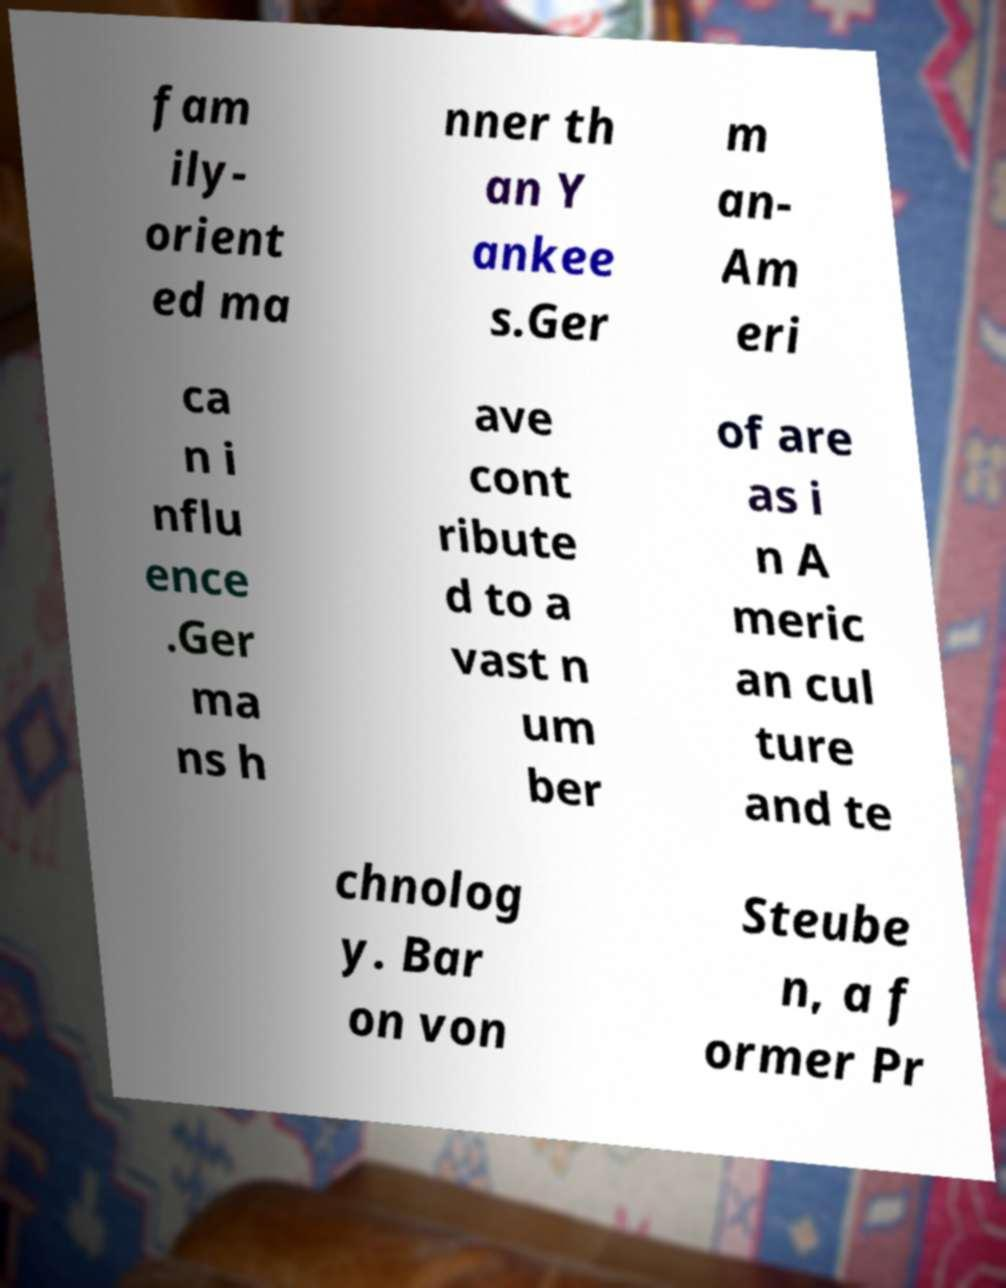Could you assist in decoding the text presented in this image and type it out clearly? fam ily- orient ed ma nner th an Y ankee s.Ger m an- Am eri ca n i nflu ence .Ger ma ns h ave cont ribute d to a vast n um ber of are as i n A meric an cul ture and te chnolog y. Bar on von Steube n, a f ormer Pr 